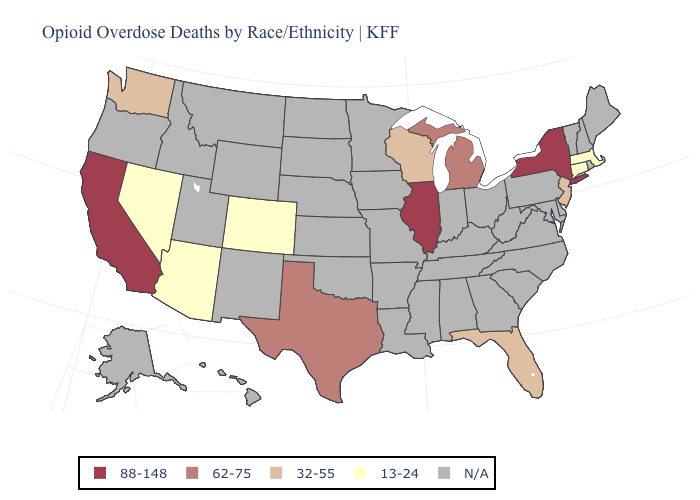Which states have the highest value in the USA?
Quick response, please. California, Illinois, New York. What is the value of South Carolina?
Give a very brief answer. N/A. Does the first symbol in the legend represent the smallest category?
Give a very brief answer. No. What is the lowest value in the MidWest?
Give a very brief answer. 32-55. What is the lowest value in the MidWest?
Be succinct. 32-55. Name the states that have a value in the range 13-24?
Be succinct. Arizona, Colorado, Connecticut, Massachusetts, Nevada. Among the states that border New Mexico , does Arizona have the highest value?
Give a very brief answer. No. Does the map have missing data?
Give a very brief answer. Yes. Name the states that have a value in the range N/A?
Write a very short answer. Alabama, Alaska, Arkansas, Delaware, Georgia, Hawaii, Idaho, Indiana, Iowa, Kansas, Kentucky, Louisiana, Maine, Maryland, Minnesota, Mississippi, Missouri, Montana, Nebraska, New Hampshire, New Mexico, North Carolina, North Dakota, Ohio, Oklahoma, Oregon, Pennsylvania, Rhode Island, South Carolina, South Dakota, Tennessee, Utah, Vermont, Virginia, West Virginia, Wyoming. Which states hav the highest value in the MidWest?
Write a very short answer. Illinois. What is the value of Washington?
Be succinct. 32-55. How many symbols are there in the legend?
Short answer required. 5. What is the highest value in states that border Arizona?
Concise answer only. 88-148. 